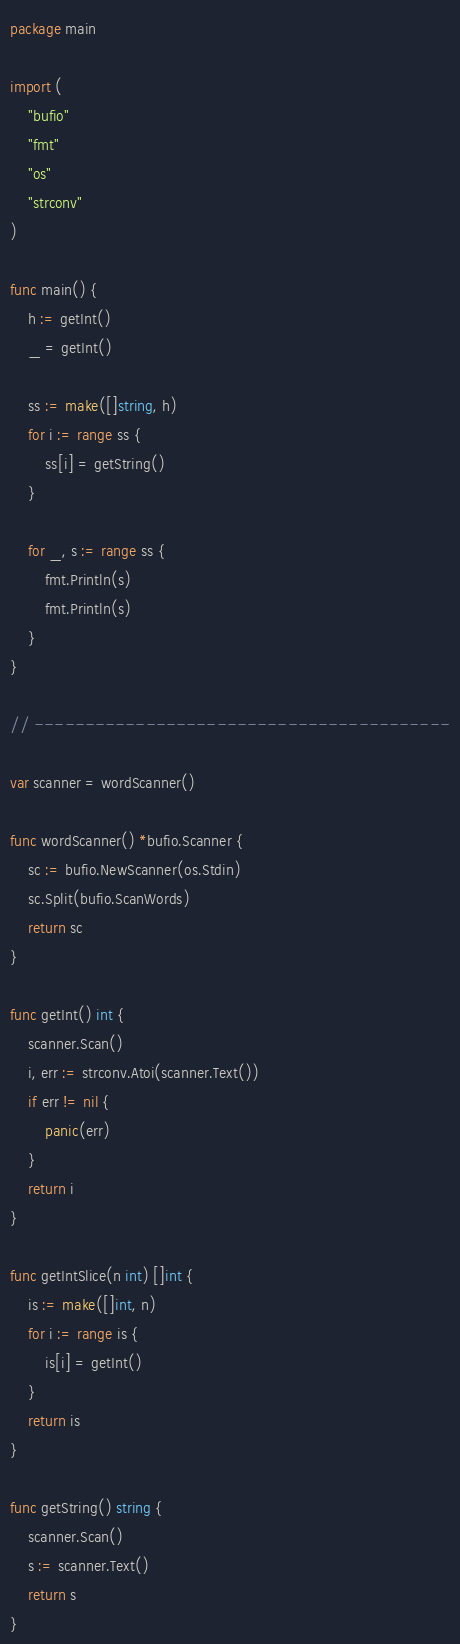<code> <loc_0><loc_0><loc_500><loc_500><_Go_>package main

import (
	"bufio"
	"fmt"
	"os"
	"strconv"
)

func main() {
	h := getInt()
	_ = getInt()

	ss := make([]string, h)
	for i := range ss {
		ss[i] = getString()
	}

	for _, s := range ss {
		fmt.Println(s)
		fmt.Println(s)
	}
}

// -----------------------------------------

var scanner = wordScanner()

func wordScanner() *bufio.Scanner {
	sc := bufio.NewScanner(os.Stdin)
	sc.Split(bufio.ScanWords)
	return sc
}

func getInt() int {
	scanner.Scan()
	i, err := strconv.Atoi(scanner.Text())
	if err != nil {
		panic(err)
	}
	return i
}

func getIntSlice(n int) []int {
	is := make([]int, n)
	for i := range is {
		is[i] = getInt()
	}
	return is
}

func getString() string {
	scanner.Scan()
	s := scanner.Text()
	return s
}
</code> 